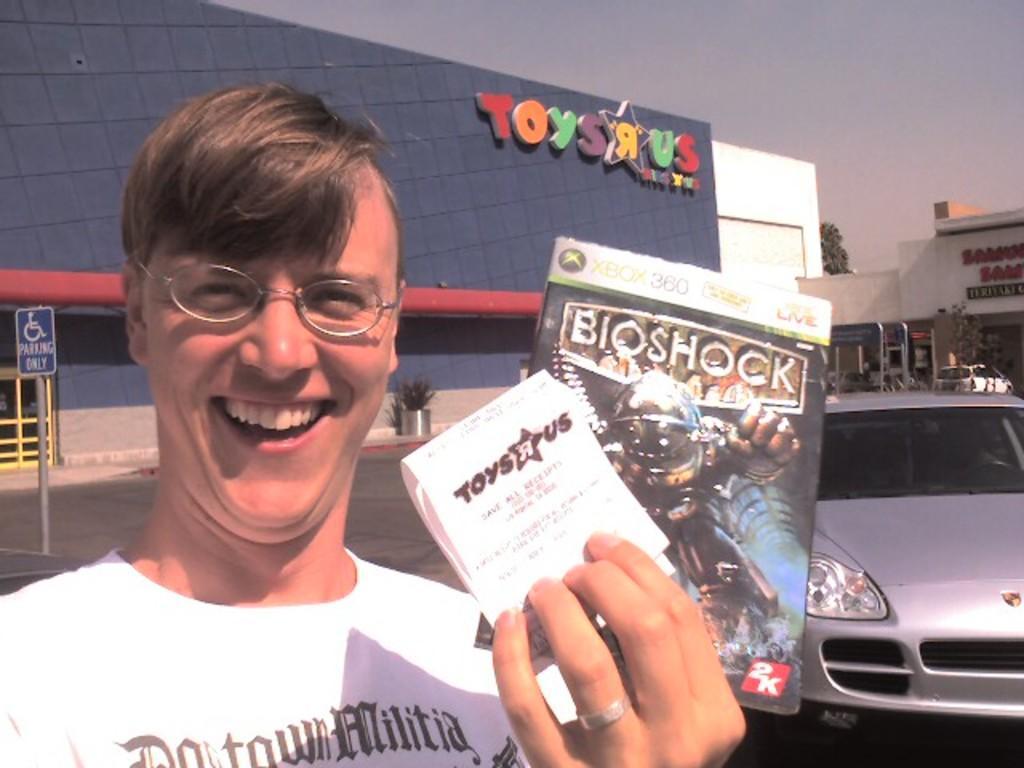Can you describe this image briefly? In this picture, there is a man towards the left. He is wearing a white t shirt and holding papers in his hand. Towards the right, there is a car which is in grey in color. In the background, there are buildings with some text. On the top, there is a sky. 